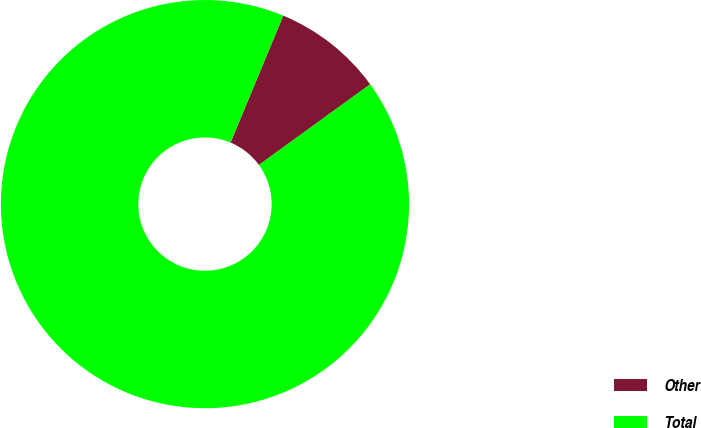<chart> <loc_0><loc_0><loc_500><loc_500><pie_chart><fcel>Other<fcel>Total<nl><fcel>8.75%<fcel>91.25%<nl></chart> 